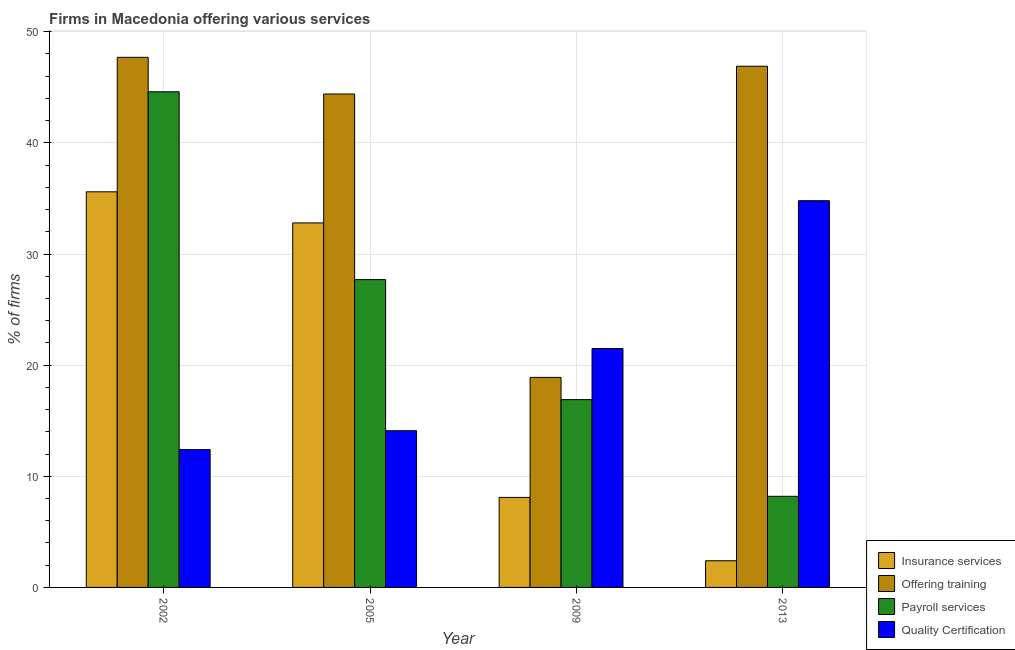How many groups of bars are there?
Your answer should be compact. 4. How many bars are there on the 2nd tick from the left?
Provide a succinct answer. 4. How many bars are there on the 3rd tick from the right?
Give a very brief answer. 4. What is the percentage of firms offering training in 2005?
Ensure brevity in your answer.  44.4. Across all years, what is the maximum percentage of firms offering insurance services?
Offer a very short reply. 35.6. In which year was the percentage of firms offering quality certification maximum?
Your answer should be compact. 2013. What is the total percentage of firms offering training in the graph?
Provide a short and direct response. 157.9. What is the difference between the percentage of firms offering quality certification in 2005 and that in 2009?
Offer a very short reply. -7.4. What is the difference between the percentage of firms offering training in 2013 and the percentage of firms offering insurance services in 2009?
Your answer should be compact. 28. What is the average percentage of firms offering insurance services per year?
Your response must be concise. 19.73. In the year 2002, what is the difference between the percentage of firms offering quality certification and percentage of firms offering payroll services?
Provide a short and direct response. 0. What is the ratio of the percentage of firms offering training in 2009 to that in 2013?
Offer a very short reply. 0.4. Is the percentage of firms offering quality certification in 2005 less than that in 2009?
Your response must be concise. Yes. Is the difference between the percentage of firms offering quality certification in 2005 and 2013 greater than the difference between the percentage of firms offering payroll services in 2005 and 2013?
Offer a very short reply. No. What is the difference between the highest and the second highest percentage of firms offering payroll services?
Your answer should be very brief. 16.9. What is the difference between the highest and the lowest percentage of firms offering quality certification?
Offer a very short reply. 22.4. What does the 4th bar from the left in 2009 represents?
Make the answer very short. Quality Certification. What does the 1st bar from the right in 2009 represents?
Ensure brevity in your answer.  Quality Certification. How many bars are there?
Make the answer very short. 16. Are all the bars in the graph horizontal?
Your response must be concise. No. How many years are there in the graph?
Provide a short and direct response. 4. What is the difference between two consecutive major ticks on the Y-axis?
Your answer should be very brief. 10. How are the legend labels stacked?
Ensure brevity in your answer.  Vertical. What is the title of the graph?
Offer a terse response. Firms in Macedonia offering various services . What is the label or title of the Y-axis?
Ensure brevity in your answer.  % of firms. What is the % of firms in Insurance services in 2002?
Offer a terse response. 35.6. What is the % of firms of Offering training in 2002?
Offer a terse response. 47.7. What is the % of firms in Payroll services in 2002?
Provide a short and direct response. 44.6. What is the % of firms in Insurance services in 2005?
Keep it short and to the point. 32.8. What is the % of firms in Offering training in 2005?
Give a very brief answer. 44.4. What is the % of firms of Payroll services in 2005?
Provide a succinct answer. 27.7. What is the % of firms of Offering training in 2009?
Make the answer very short. 18.9. What is the % of firms of Quality Certification in 2009?
Your answer should be compact. 21.5. What is the % of firms of Offering training in 2013?
Provide a short and direct response. 46.9. What is the % of firms in Quality Certification in 2013?
Provide a succinct answer. 34.8. Across all years, what is the maximum % of firms in Insurance services?
Offer a very short reply. 35.6. Across all years, what is the maximum % of firms in Offering training?
Your response must be concise. 47.7. Across all years, what is the maximum % of firms in Payroll services?
Offer a very short reply. 44.6. Across all years, what is the maximum % of firms of Quality Certification?
Ensure brevity in your answer.  34.8. Across all years, what is the minimum % of firms in Offering training?
Your answer should be compact. 18.9. Across all years, what is the minimum % of firms in Payroll services?
Your answer should be compact. 8.2. Across all years, what is the minimum % of firms of Quality Certification?
Keep it short and to the point. 12.4. What is the total % of firms in Insurance services in the graph?
Make the answer very short. 78.9. What is the total % of firms in Offering training in the graph?
Keep it short and to the point. 157.9. What is the total % of firms in Payroll services in the graph?
Your answer should be very brief. 97.4. What is the total % of firms of Quality Certification in the graph?
Your answer should be very brief. 82.8. What is the difference between the % of firms in Offering training in 2002 and that in 2005?
Keep it short and to the point. 3.3. What is the difference between the % of firms in Payroll services in 2002 and that in 2005?
Your answer should be very brief. 16.9. What is the difference between the % of firms of Quality Certification in 2002 and that in 2005?
Your answer should be very brief. -1.7. What is the difference between the % of firms in Insurance services in 2002 and that in 2009?
Make the answer very short. 27.5. What is the difference between the % of firms in Offering training in 2002 and that in 2009?
Make the answer very short. 28.8. What is the difference between the % of firms of Payroll services in 2002 and that in 2009?
Provide a succinct answer. 27.7. What is the difference between the % of firms of Insurance services in 2002 and that in 2013?
Your response must be concise. 33.2. What is the difference between the % of firms of Payroll services in 2002 and that in 2013?
Offer a terse response. 36.4. What is the difference between the % of firms of Quality Certification in 2002 and that in 2013?
Your answer should be compact. -22.4. What is the difference between the % of firms in Insurance services in 2005 and that in 2009?
Your response must be concise. 24.7. What is the difference between the % of firms of Payroll services in 2005 and that in 2009?
Give a very brief answer. 10.8. What is the difference between the % of firms of Insurance services in 2005 and that in 2013?
Your answer should be very brief. 30.4. What is the difference between the % of firms in Offering training in 2005 and that in 2013?
Offer a terse response. -2.5. What is the difference between the % of firms of Quality Certification in 2005 and that in 2013?
Your answer should be very brief. -20.7. What is the difference between the % of firms of Quality Certification in 2009 and that in 2013?
Ensure brevity in your answer.  -13.3. What is the difference between the % of firms of Insurance services in 2002 and the % of firms of Offering training in 2005?
Give a very brief answer. -8.8. What is the difference between the % of firms of Insurance services in 2002 and the % of firms of Payroll services in 2005?
Give a very brief answer. 7.9. What is the difference between the % of firms of Offering training in 2002 and the % of firms of Payroll services in 2005?
Offer a terse response. 20. What is the difference between the % of firms of Offering training in 2002 and the % of firms of Quality Certification in 2005?
Your answer should be very brief. 33.6. What is the difference between the % of firms of Payroll services in 2002 and the % of firms of Quality Certification in 2005?
Your answer should be very brief. 30.5. What is the difference between the % of firms of Insurance services in 2002 and the % of firms of Offering training in 2009?
Keep it short and to the point. 16.7. What is the difference between the % of firms in Insurance services in 2002 and the % of firms in Payroll services in 2009?
Make the answer very short. 18.7. What is the difference between the % of firms of Insurance services in 2002 and the % of firms of Quality Certification in 2009?
Provide a succinct answer. 14.1. What is the difference between the % of firms of Offering training in 2002 and the % of firms of Payroll services in 2009?
Keep it short and to the point. 30.8. What is the difference between the % of firms of Offering training in 2002 and the % of firms of Quality Certification in 2009?
Your answer should be very brief. 26.2. What is the difference between the % of firms in Payroll services in 2002 and the % of firms in Quality Certification in 2009?
Provide a short and direct response. 23.1. What is the difference between the % of firms of Insurance services in 2002 and the % of firms of Offering training in 2013?
Offer a very short reply. -11.3. What is the difference between the % of firms of Insurance services in 2002 and the % of firms of Payroll services in 2013?
Your answer should be very brief. 27.4. What is the difference between the % of firms of Insurance services in 2002 and the % of firms of Quality Certification in 2013?
Your answer should be very brief. 0.8. What is the difference between the % of firms of Offering training in 2002 and the % of firms of Payroll services in 2013?
Your response must be concise. 39.5. What is the difference between the % of firms of Insurance services in 2005 and the % of firms of Offering training in 2009?
Provide a succinct answer. 13.9. What is the difference between the % of firms of Offering training in 2005 and the % of firms of Payroll services in 2009?
Your answer should be very brief. 27.5. What is the difference between the % of firms of Offering training in 2005 and the % of firms of Quality Certification in 2009?
Give a very brief answer. 22.9. What is the difference between the % of firms of Payroll services in 2005 and the % of firms of Quality Certification in 2009?
Keep it short and to the point. 6.2. What is the difference between the % of firms in Insurance services in 2005 and the % of firms in Offering training in 2013?
Provide a short and direct response. -14.1. What is the difference between the % of firms in Insurance services in 2005 and the % of firms in Payroll services in 2013?
Offer a very short reply. 24.6. What is the difference between the % of firms in Offering training in 2005 and the % of firms in Payroll services in 2013?
Your response must be concise. 36.2. What is the difference between the % of firms in Offering training in 2005 and the % of firms in Quality Certification in 2013?
Your response must be concise. 9.6. What is the difference between the % of firms of Insurance services in 2009 and the % of firms of Offering training in 2013?
Ensure brevity in your answer.  -38.8. What is the difference between the % of firms in Insurance services in 2009 and the % of firms in Quality Certification in 2013?
Provide a short and direct response. -26.7. What is the difference between the % of firms in Offering training in 2009 and the % of firms in Quality Certification in 2013?
Keep it short and to the point. -15.9. What is the difference between the % of firms of Payroll services in 2009 and the % of firms of Quality Certification in 2013?
Give a very brief answer. -17.9. What is the average % of firms of Insurance services per year?
Give a very brief answer. 19.73. What is the average % of firms in Offering training per year?
Your answer should be very brief. 39.48. What is the average % of firms in Payroll services per year?
Offer a terse response. 24.35. What is the average % of firms of Quality Certification per year?
Make the answer very short. 20.7. In the year 2002, what is the difference between the % of firms in Insurance services and % of firms in Payroll services?
Your response must be concise. -9. In the year 2002, what is the difference between the % of firms in Insurance services and % of firms in Quality Certification?
Your response must be concise. 23.2. In the year 2002, what is the difference between the % of firms in Offering training and % of firms in Payroll services?
Provide a short and direct response. 3.1. In the year 2002, what is the difference between the % of firms of Offering training and % of firms of Quality Certification?
Make the answer very short. 35.3. In the year 2002, what is the difference between the % of firms in Payroll services and % of firms in Quality Certification?
Make the answer very short. 32.2. In the year 2005, what is the difference between the % of firms of Insurance services and % of firms of Quality Certification?
Make the answer very short. 18.7. In the year 2005, what is the difference between the % of firms of Offering training and % of firms of Quality Certification?
Your response must be concise. 30.3. In the year 2009, what is the difference between the % of firms in Insurance services and % of firms in Offering training?
Provide a short and direct response. -10.8. In the year 2009, what is the difference between the % of firms of Insurance services and % of firms of Payroll services?
Your response must be concise. -8.8. In the year 2009, what is the difference between the % of firms of Insurance services and % of firms of Quality Certification?
Provide a short and direct response. -13.4. In the year 2009, what is the difference between the % of firms of Offering training and % of firms of Payroll services?
Give a very brief answer. 2. In the year 2013, what is the difference between the % of firms of Insurance services and % of firms of Offering training?
Your answer should be very brief. -44.5. In the year 2013, what is the difference between the % of firms of Insurance services and % of firms of Payroll services?
Provide a short and direct response. -5.8. In the year 2013, what is the difference between the % of firms in Insurance services and % of firms in Quality Certification?
Offer a very short reply. -32.4. In the year 2013, what is the difference between the % of firms in Offering training and % of firms in Payroll services?
Provide a succinct answer. 38.7. In the year 2013, what is the difference between the % of firms of Payroll services and % of firms of Quality Certification?
Give a very brief answer. -26.6. What is the ratio of the % of firms of Insurance services in 2002 to that in 2005?
Your answer should be very brief. 1.09. What is the ratio of the % of firms of Offering training in 2002 to that in 2005?
Ensure brevity in your answer.  1.07. What is the ratio of the % of firms in Payroll services in 2002 to that in 2005?
Give a very brief answer. 1.61. What is the ratio of the % of firms in Quality Certification in 2002 to that in 2005?
Your response must be concise. 0.88. What is the ratio of the % of firms of Insurance services in 2002 to that in 2009?
Your answer should be very brief. 4.4. What is the ratio of the % of firms of Offering training in 2002 to that in 2009?
Provide a short and direct response. 2.52. What is the ratio of the % of firms of Payroll services in 2002 to that in 2009?
Offer a terse response. 2.64. What is the ratio of the % of firms in Quality Certification in 2002 to that in 2009?
Your answer should be very brief. 0.58. What is the ratio of the % of firms in Insurance services in 2002 to that in 2013?
Provide a succinct answer. 14.83. What is the ratio of the % of firms of Offering training in 2002 to that in 2013?
Make the answer very short. 1.02. What is the ratio of the % of firms of Payroll services in 2002 to that in 2013?
Provide a short and direct response. 5.44. What is the ratio of the % of firms of Quality Certification in 2002 to that in 2013?
Provide a succinct answer. 0.36. What is the ratio of the % of firms of Insurance services in 2005 to that in 2009?
Provide a short and direct response. 4.05. What is the ratio of the % of firms in Offering training in 2005 to that in 2009?
Your response must be concise. 2.35. What is the ratio of the % of firms in Payroll services in 2005 to that in 2009?
Your answer should be compact. 1.64. What is the ratio of the % of firms of Quality Certification in 2005 to that in 2009?
Your response must be concise. 0.66. What is the ratio of the % of firms in Insurance services in 2005 to that in 2013?
Give a very brief answer. 13.67. What is the ratio of the % of firms in Offering training in 2005 to that in 2013?
Give a very brief answer. 0.95. What is the ratio of the % of firms in Payroll services in 2005 to that in 2013?
Give a very brief answer. 3.38. What is the ratio of the % of firms in Quality Certification in 2005 to that in 2013?
Make the answer very short. 0.41. What is the ratio of the % of firms of Insurance services in 2009 to that in 2013?
Give a very brief answer. 3.38. What is the ratio of the % of firms in Offering training in 2009 to that in 2013?
Offer a very short reply. 0.4. What is the ratio of the % of firms in Payroll services in 2009 to that in 2013?
Keep it short and to the point. 2.06. What is the ratio of the % of firms in Quality Certification in 2009 to that in 2013?
Offer a terse response. 0.62. What is the difference between the highest and the second highest % of firms of Quality Certification?
Your answer should be very brief. 13.3. What is the difference between the highest and the lowest % of firms of Insurance services?
Keep it short and to the point. 33.2. What is the difference between the highest and the lowest % of firms of Offering training?
Make the answer very short. 28.8. What is the difference between the highest and the lowest % of firms in Payroll services?
Your answer should be very brief. 36.4. What is the difference between the highest and the lowest % of firms of Quality Certification?
Your response must be concise. 22.4. 